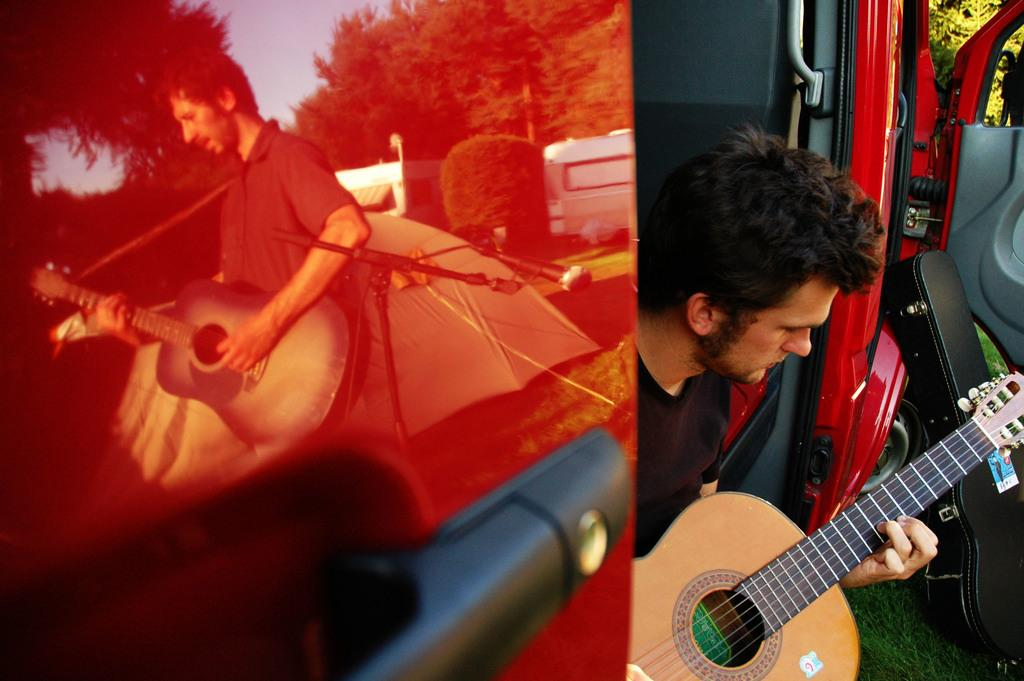What is the main activity being performed in the image? There are two guys playing guitars in the image. Where are the guys playing guitars located? The guys are sitting inside a red car. Can you describe the position of the second guy's shadow in the image? The second guy's shadow is on the red car door. What type of hospital can be seen in the background of the image? There is no hospital present in the image; it features two guys playing guitars inside a red car. 